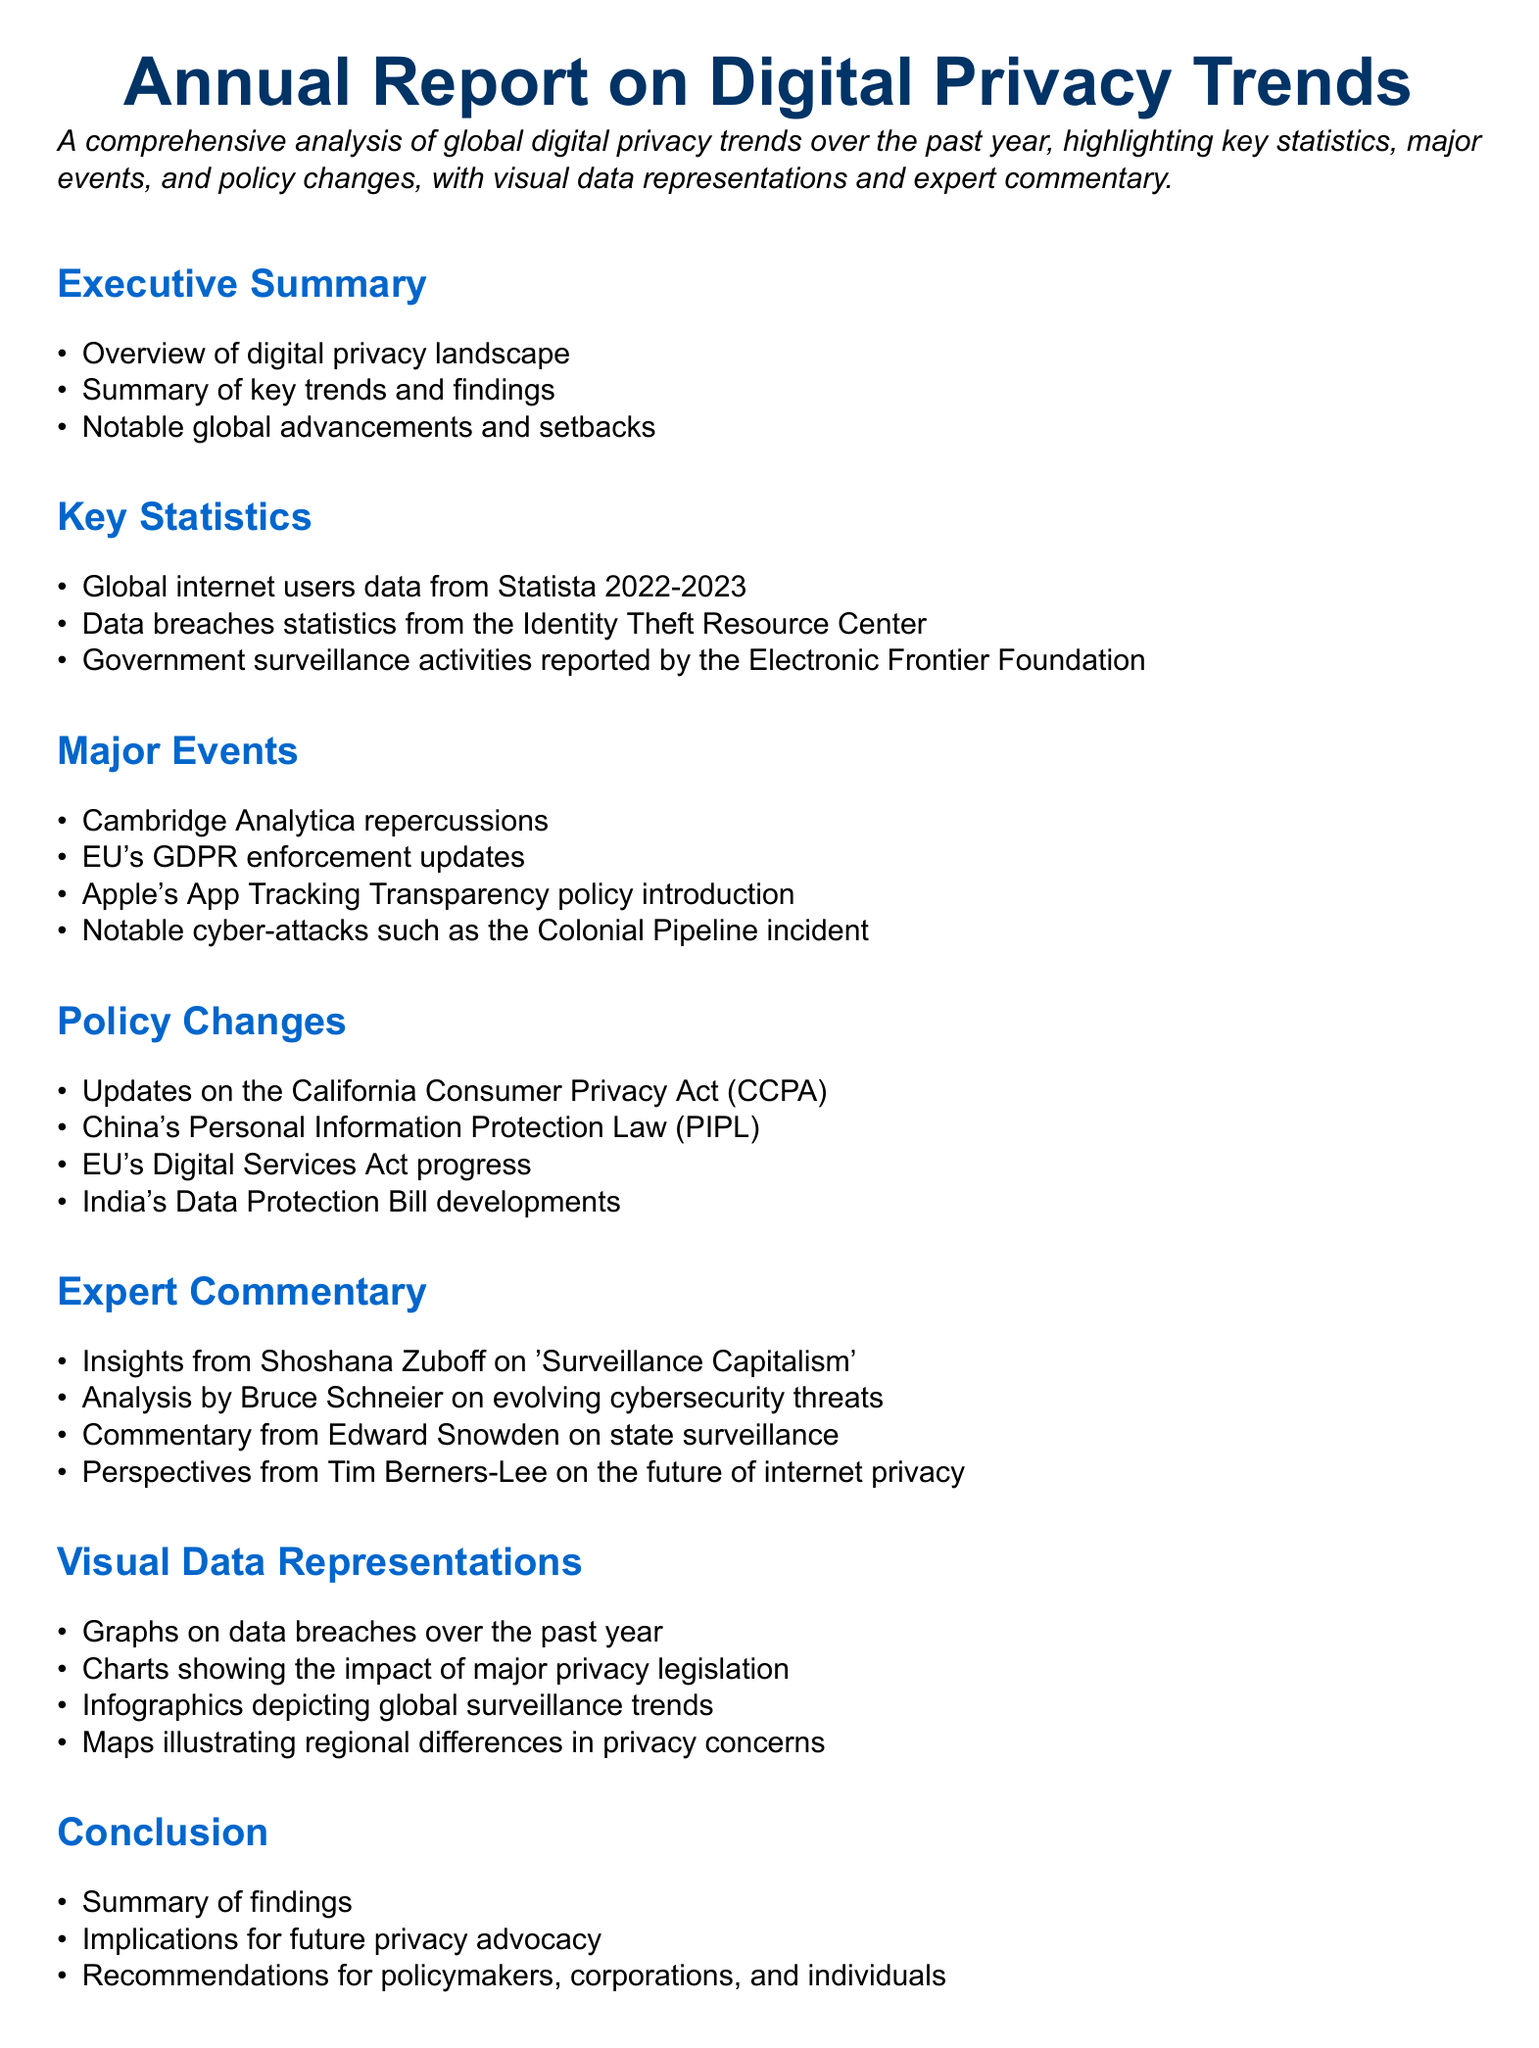What is the focus of the Annual Report on Digital Privacy Trends? The report provides a comprehensive analysis of global digital privacy trends over the past year, highlighting key statistics, major events, and policy changes.
Answer: Global digital privacy trends How many key areas are highlighted in the Executive Summary? The Executive Summary lists three key areas regarding digital privacy: overview, summary of trends, and notable advancements or setbacks.
Answer: Three Which law is discussed under Policy Changes regarding California? The California Consumer Privacy Act (CCPA) is mentioned as an updated regulation in Policy Changes.
Answer: CCPA Who provided insights on 'Surveillance Capitalism' mentioned in Expert Commentary? Shoshana Zuboff is the expert noted for her insights on 'Surveillance Capitalism'.
Answer: Shoshana Zuboff What significant event involved Cambridge Analytica? The repercussions of the Cambridge Analytica incident are highlighted as a major event in the document.
Answer: Cambridge Analytica repercussions Which country implemented the Personal Information Protection Law? The document discusses China's adoption of the Personal Information Protection Law as a notable policy change.
Answer: China What is one of the visual data representations included in the report? The report includes graphs on data breaches over the past year as part of its visual data representations.
Answer: Graphs on data breaches How does the report summarize its findings? The conclusion of the report summarizes the findings and discusses implications for privacy advocacy moving forward.
Answer: Summary of findings What is the author's perspective on the future of internet privacy? Tim Berners-Lee provides commentary in the section discussing future perspectives on internet privacy.
Answer: Tim Berners-Lee 